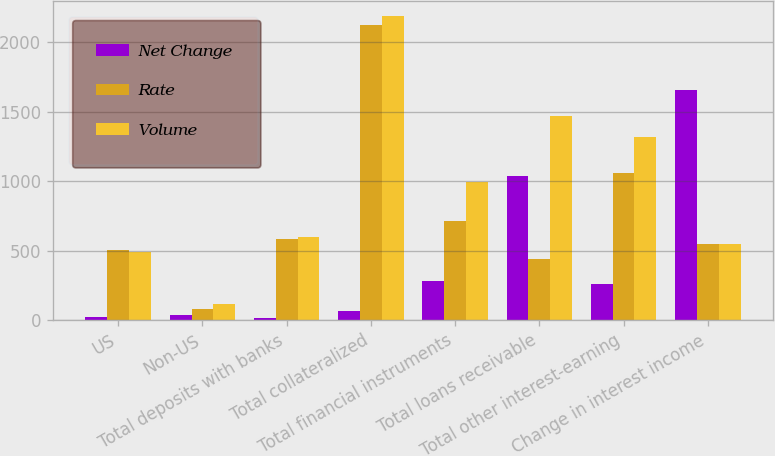Convert chart. <chart><loc_0><loc_0><loc_500><loc_500><stacked_bar_chart><ecel><fcel>US<fcel>Non-US<fcel>Total deposits with banks<fcel>Total collateralized<fcel>Total financial instruments<fcel>Total loans receivable<fcel>Total other interest-earning<fcel>Change in interest income<nl><fcel>Net Change<fcel>18<fcel>34<fcel>16<fcel>66<fcel>279<fcel>1034<fcel>259<fcel>1654<nl><fcel>Rate<fcel>505<fcel>78<fcel>583<fcel>2125<fcel>711<fcel>436<fcel>1057<fcel>544<nl><fcel>Volume<fcel>487<fcel>112<fcel>599<fcel>2191<fcel>990<fcel>1470<fcel>1316<fcel>544<nl></chart> 